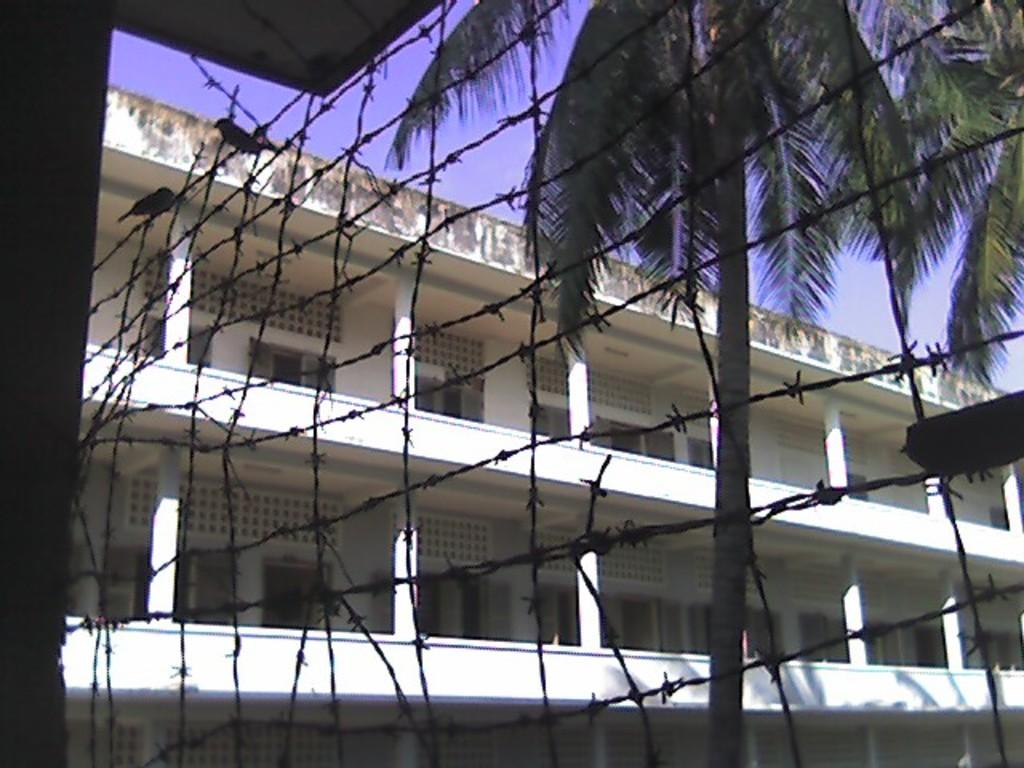What type of barrier is present in the image? There is an iron fence in the image. What can be seen in the background of the image? There are trees and a building with windows in the background of the image. What is visible in the sky in the image? There are clouds in the sky in the image. What type of card is being used to grip the iron fence in the image? There is no card present in the image, nor is anyone gripping the iron fence. 